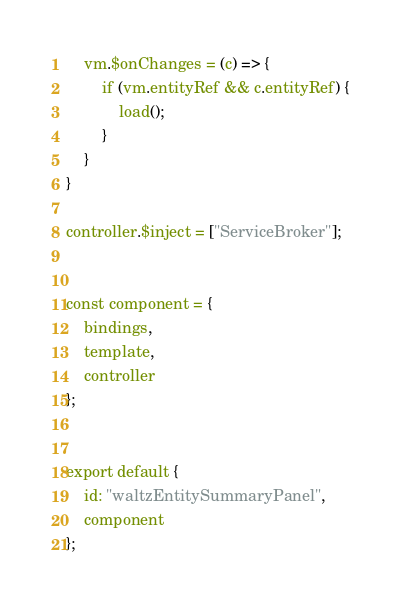<code> <loc_0><loc_0><loc_500><loc_500><_JavaScript_>    vm.$onChanges = (c) => {
        if (vm.entityRef && c.entityRef) {
            load();
        }
    }
}

controller.$inject = ["ServiceBroker"];


const component = {
    bindings,
    template,
    controller
};


export default {
    id: "waltzEntitySummaryPanel",
    component
};</code> 